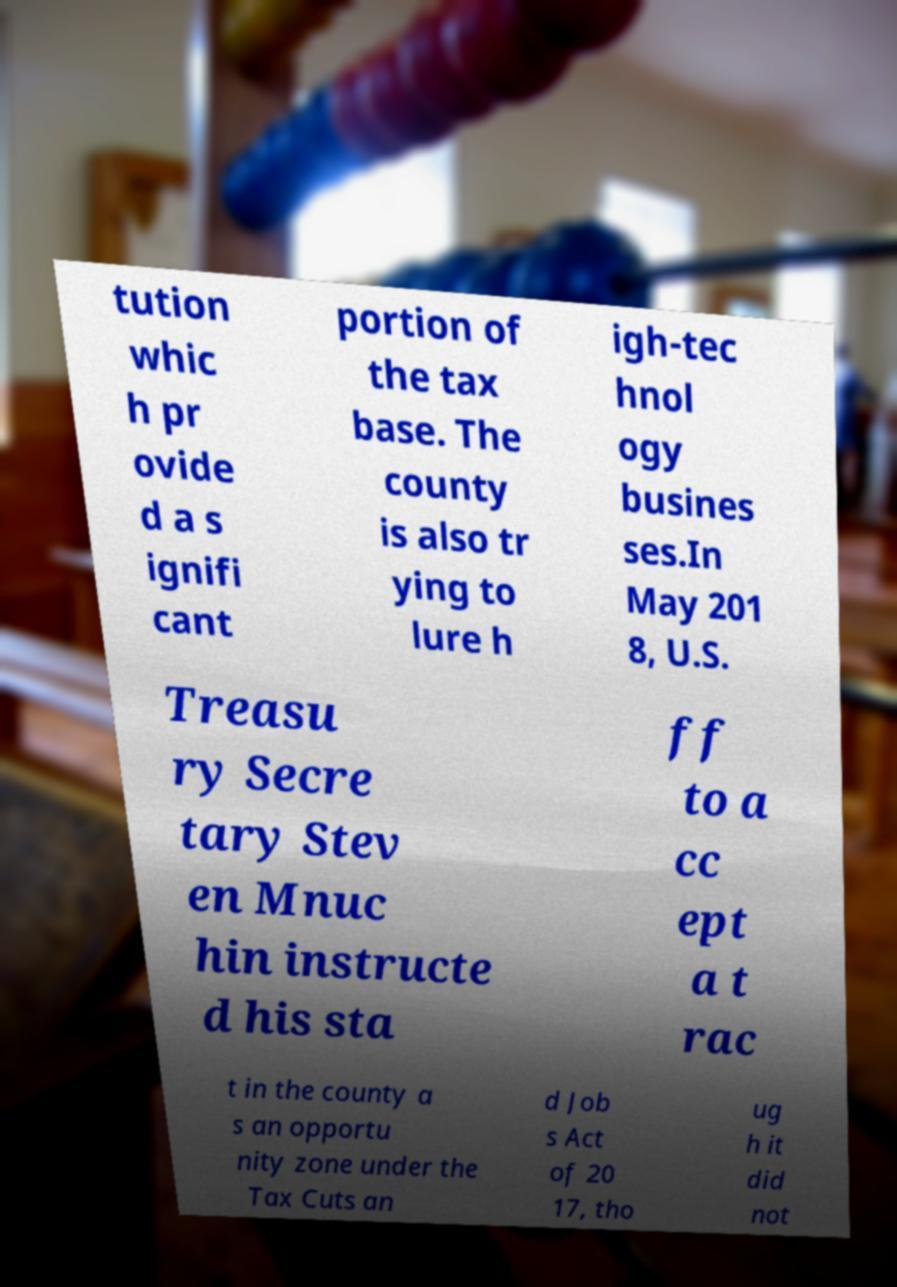Could you assist in decoding the text presented in this image and type it out clearly? tution whic h pr ovide d a s ignifi cant portion of the tax base. The county is also tr ying to lure h igh-tec hnol ogy busines ses.In May 201 8, U.S. Treasu ry Secre tary Stev en Mnuc hin instructe d his sta ff to a cc ept a t rac t in the county a s an opportu nity zone under the Tax Cuts an d Job s Act of 20 17, tho ug h it did not 